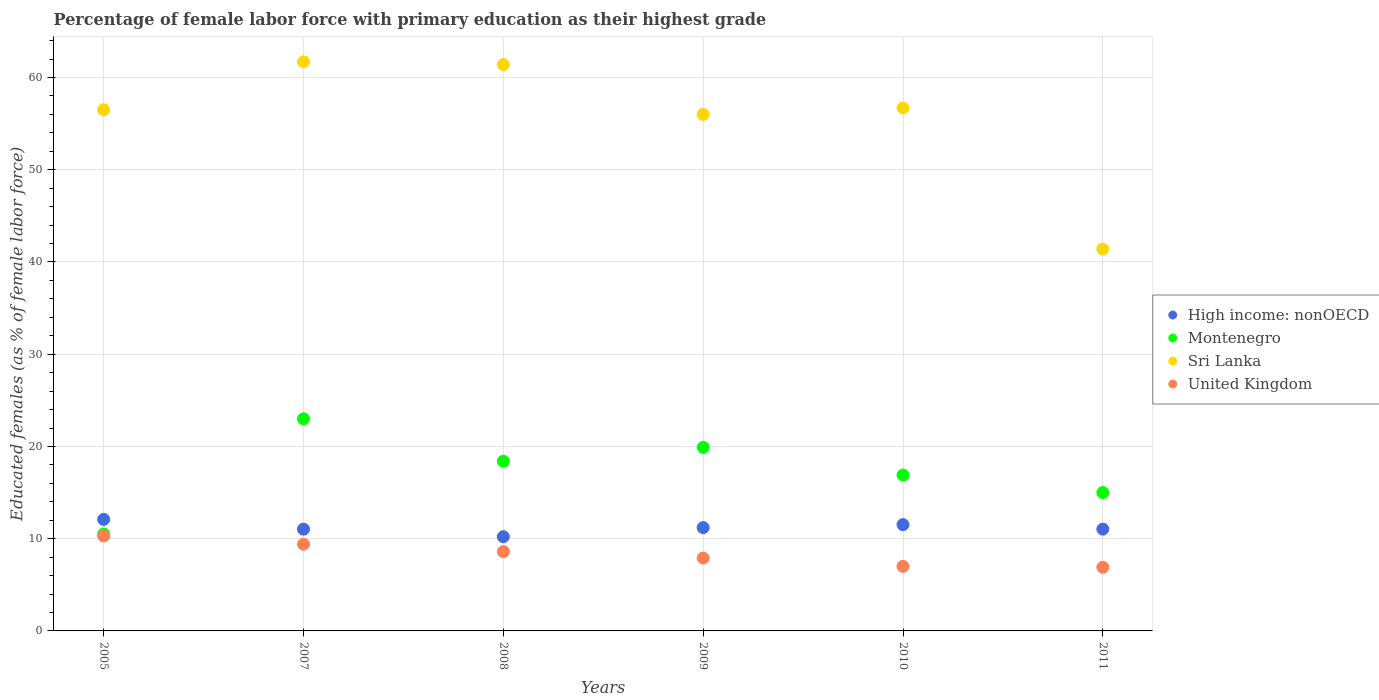Is the number of dotlines equal to the number of legend labels?
Ensure brevity in your answer.  Yes. What is the percentage of female labor force with primary education in United Kingdom in 2007?
Keep it short and to the point. 9.4. Across all years, what is the maximum percentage of female labor force with primary education in Montenegro?
Ensure brevity in your answer.  23. Across all years, what is the minimum percentage of female labor force with primary education in High income: nonOECD?
Give a very brief answer. 10.21. In which year was the percentage of female labor force with primary education in United Kingdom maximum?
Your answer should be very brief. 2005. In which year was the percentage of female labor force with primary education in High income: nonOECD minimum?
Ensure brevity in your answer.  2008. What is the total percentage of female labor force with primary education in United Kingdom in the graph?
Offer a terse response. 50.1. What is the difference between the percentage of female labor force with primary education in Sri Lanka in 2009 and that in 2011?
Your answer should be very brief. 14.6. What is the difference between the percentage of female labor force with primary education in Montenegro in 2011 and the percentage of female labor force with primary education in Sri Lanka in 2010?
Give a very brief answer. -41.7. What is the average percentage of female labor force with primary education in Montenegro per year?
Make the answer very short. 17.28. In the year 2007, what is the difference between the percentage of female labor force with primary education in High income: nonOECD and percentage of female labor force with primary education in Montenegro?
Make the answer very short. -11.97. In how many years, is the percentage of female labor force with primary education in Montenegro greater than 24 %?
Offer a terse response. 0. What is the ratio of the percentage of female labor force with primary education in High income: nonOECD in 2007 to that in 2011?
Make the answer very short. 1. Is the difference between the percentage of female labor force with primary education in High income: nonOECD in 2008 and 2011 greater than the difference between the percentage of female labor force with primary education in Montenegro in 2008 and 2011?
Give a very brief answer. No. What is the difference between the highest and the second highest percentage of female labor force with primary education in Sri Lanka?
Your answer should be very brief. 0.3. What is the difference between the highest and the lowest percentage of female labor force with primary education in United Kingdom?
Ensure brevity in your answer.  3.4. Is the sum of the percentage of female labor force with primary education in Sri Lanka in 2005 and 2009 greater than the maximum percentage of female labor force with primary education in Montenegro across all years?
Make the answer very short. Yes. Does the percentage of female labor force with primary education in Montenegro monotonically increase over the years?
Your response must be concise. No. How many dotlines are there?
Keep it short and to the point. 4. How many years are there in the graph?
Give a very brief answer. 6. What is the difference between two consecutive major ticks on the Y-axis?
Make the answer very short. 10. Does the graph contain any zero values?
Give a very brief answer. No. How many legend labels are there?
Keep it short and to the point. 4. How are the legend labels stacked?
Provide a succinct answer. Vertical. What is the title of the graph?
Make the answer very short. Percentage of female labor force with primary education as their highest grade. Does "Seychelles" appear as one of the legend labels in the graph?
Your answer should be compact. No. What is the label or title of the Y-axis?
Give a very brief answer. Educated females (as % of female labor force). What is the Educated females (as % of female labor force) of High income: nonOECD in 2005?
Keep it short and to the point. 12.09. What is the Educated females (as % of female labor force) in Montenegro in 2005?
Give a very brief answer. 10.5. What is the Educated females (as % of female labor force) in Sri Lanka in 2005?
Make the answer very short. 56.5. What is the Educated females (as % of female labor force) of United Kingdom in 2005?
Provide a short and direct response. 10.3. What is the Educated females (as % of female labor force) in High income: nonOECD in 2007?
Provide a succinct answer. 11.03. What is the Educated females (as % of female labor force) in Sri Lanka in 2007?
Provide a succinct answer. 61.7. What is the Educated females (as % of female labor force) of United Kingdom in 2007?
Provide a succinct answer. 9.4. What is the Educated females (as % of female labor force) of High income: nonOECD in 2008?
Provide a short and direct response. 10.21. What is the Educated females (as % of female labor force) of Montenegro in 2008?
Offer a very short reply. 18.4. What is the Educated females (as % of female labor force) in Sri Lanka in 2008?
Your answer should be compact. 61.4. What is the Educated females (as % of female labor force) in United Kingdom in 2008?
Your response must be concise. 8.6. What is the Educated females (as % of female labor force) of High income: nonOECD in 2009?
Give a very brief answer. 11.2. What is the Educated females (as % of female labor force) in Montenegro in 2009?
Ensure brevity in your answer.  19.9. What is the Educated females (as % of female labor force) in United Kingdom in 2009?
Provide a short and direct response. 7.9. What is the Educated females (as % of female labor force) in High income: nonOECD in 2010?
Your answer should be very brief. 11.53. What is the Educated females (as % of female labor force) of Montenegro in 2010?
Give a very brief answer. 16.9. What is the Educated females (as % of female labor force) in Sri Lanka in 2010?
Your response must be concise. 56.7. What is the Educated females (as % of female labor force) in United Kingdom in 2010?
Offer a terse response. 7. What is the Educated females (as % of female labor force) in High income: nonOECD in 2011?
Make the answer very short. 11.03. What is the Educated females (as % of female labor force) in Montenegro in 2011?
Your answer should be compact. 15. What is the Educated females (as % of female labor force) in Sri Lanka in 2011?
Offer a very short reply. 41.4. What is the Educated females (as % of female labor force) of United Kingdom in 2011?
Your answer should be compact. 6.9. Across all years, what is the maximum Educated females (as % of female labor force) in High income: nonOECD?
Give a very brief answer. 12.09. Across all years, what is the maximum Educated females (as % of female labor force) of Sri Lanka?
Keep it short and to the point. 61.7. Across all years, what is the maximum Educated females (as % of female labor force) of United Kingdom?
Make the answer very short. 10.3. Across all years, what is the minimum Educated females (as % of female labor force) in High income: nonOECD?
Offer a very short reply. 10.21. Across all years, what is the minimum Educated females (as % of female labor force) in Sri Lanka?
Keep it short and to the point. 41.4. Across all years, what is the minimum Educated females (as % of female labor force) in United Kingdom?
Provide a succinct answer. 6.9. What is the total Educated females (as % of female labor force) in High income: nonOECD in the graph?
Make the answer very short. 67.1. What is the total Educated females (as % of female labor force) in Montenegro in the graph?
Make the answer very short. 103.7. What is the total Educated females (as % of female labor force) of Sri Lanka in the graph?
Your answer should be very brief. 333.7. What is the total Educated females (as % of female labor force) in United Kingdom in the graph?
Your answer should be compact. 50.1. What is the difference between the Educated females (as % of female labor force) in High income: nonOECD in 2005 and that in 2007?
Make the answer very short. 1.06. What is the difference between the Educated females (as % of female labor force) of Montenegro in 2005 and that in 2007?
Provide a succinct answer. -12.5. What is the difference between the Educated females (as % of female labor force) in Sri Lanka in 2005 and that in 2007?
Provide a short and direct response. -5.2. What is the difference between the Educated females (as % of female labor force) in High income: nonOECD in 2005 and that in 2008?
Offer a terse response. 1.88. What is the difference between the Educated females (as % of female labor force) in Montenegro in 2005 and that in 2008?
Provide a short and direct response. -7.9. What is the difference between the Educated females (as % of female labor force) of United Kingdom in 2005 and that in 2008?
Ensure brevity in your answer.  1.7. What is the difference between the Educated females (as % of female labor force) in High income: nonOECD in 2005 and that in 2009?
Offer a terse response. 0.89. What is the difference between the Educated females (as % of female labor force) of Montenegro in 2005 and that in 2009?
Your response must be concise. -9.4. What is the difference between the Educated females (as % of female labor force) in High income: nonOECD in 2005 and that in 2010?
Provide a succinct answer. 0.57. What is the difference between the Educated females (as % of female labor force) of High income: nonOECD in 2005 and that in 2011?
Offer a very short reply. 1.06. What is the difference between the Educated females (as % of female labor force) of Sri Lanka in 2005 and that in 2011?
Your answer should be very brief. 15.1. What is the difference between the Educated females (as % of female labor force) in High income: nonOECD in 2007 and that in 2008?
Ensure brevity in your answer.  0.82. What is the difference between the Educated females (as % of female labor force) of Montenegro in 2007 and that in 2008?
Offer a terse response. 4.6. What is the difference between the Educated females (as % of female labor force) in Sri Lanka in 2007 and that in 2008?
Offer a very short reply. 0.3. What is the difference between the Educated females (as % of female labor force) of United Kingdom in 2007 and that in 2008?
Provide a succinct answer. 0.8. What is the difference between the Educated females (as % of female labor force) in High income: nonOECD in 2007 and that in 2009?
Your answer should be compact. -0.17. What is the difference between the Educated females (as % of female labor force) in United Kingdom in 2007 and that in 2009?
Your response must be concise. 1.5. What is the difference between the Educated females (as % of female labor force) in High income: nonOECD in 2007 and that in 2010?
Offer a very short reply. -0.49. What is the difference between the Educated females (as % of female labor force) in Montenegro in 2007 and that in 2010?
Your response must be concise. 6.1. What is the difference between the Educated females (as % of female labor force) in Sri Lanka in 2007 and that in 2010?
Your response must be concise. 5. What is the difference between the Educated females (as % of female labor force) of United Kingdom in 2007 and that in 2010?
Give a very brief answer. 2.4. What is the difference between the Educated females (as % of female labor force) of High income: nonOECD in 2007 and that in 2011?
Your answer should be very brief. -0. What is the difference between the Educated females (as % of female labor force) of Sri Lanka in 2007 and that in 2011?
Your answer should be compact. 20.3. What is the difference between the Educated females (as % of female labor force) of High income: nonOECD in 2008 and that in 2009?
Your answer should be compact. -0.99. What is the difference between the Educated females (as % of female labor force) in Montenegro in 2008 and that in 2009?
Your response must be concise. -1.5. What is the difference between the Educated females (as % of female labor force) in Sri Lanka in 2008 and that in 2009?
Make the answer very short. 5.4. What is the difference between the Educated females (as % of female labor force) in High income: nonOECD in 2008 and that in 2010?
Your answer should be compact. -1.31. What is the difference between the Educated females (as % of female labor force) of Montenegro in 2008 and that in 2010?
Keep it short and to the point. 1.5. What is the difference between the Educated females (as % of female labor force) of High income: nonOECD in 2008 and that in 2011?
Offer a very short reply. -0.82. What is the difference between the Educated females (as % of female labor force) in Montenegro in 2008 and that in 2011?
Give a very brief answer. 3.4. What is the difference between the Educated females (as % of female labor force) in United Kingdom in 2008 and that in 2011?
Make the answer very short. 1.7. What is the difference between the Educated females (as % of female labor force) of High income: nonOECD in 2009 and that in 2010?
Your answer should be compact. -0.33. What is the difference between the Educated females (as % of female labor force) of Sri Lanka in 2009 and that in 2010?
Give a very brief answer. -0.7. What is the difference between the Educated females (as % of female labor force) of United Kingdom in 2009 and that in 2010?
Make the answer very short. 0.9. What is the difference between the Educated females (as % of female labor force) of High income: nonOECD in 2009 and that in 2011?
Your answer should be very brief. 0.17. What is the difference between the Educated females (as % of female labor force) in United Kingdom in 2009 and that in 2011?
Provide a short and direct response. 1. What is the difference between the Educated females (as % of female labor force) in High income: nonOECD in 2010 and that in 2011?
Offer a terse response. 0.49. What is the difference between the Educated females (as % of female labor force) in United Kingdom in 2010 and that in 2011?
Ensure brevity in your answer.  0.1. What is the difference between the Educated females (as % of female labor force) of High income: nonOECD in 2005 and the Educated females (as % of female labor force) of Montenegro in 2007?
Offer a terse response. -10.91. What is the difference between the Educated females (as % of female labor force) in High income: nonOECD in 2005 and the Educated females (as % of female labor force) in Sri Lanka in 2007?
Provide a short and direct response. -49.61. What is the difference between the Educated females (as % of female labor force) of High income: nonOECD in 2005 and the Educated females (as % of female labor force) of United Kingdom in 2007?
Provide a succinct answer. 2.69. What is the difference between the Educated females (as % of female labor force) of Montenegro in 2005 and the Educated females (as % of female labor force) of Sri Lanka in 2007?
Keep it short and to the point. -51.2. What is the difference between the Educated females (as % of female labor force) of Montenegro in 2005 and the Educated females (as % of female labor force) of United Kingdom in 2007?
Offer a terse response. 1.1. What is the difference between the Educated females (as % of female labor force) of Sri Lanka in 2005 and the Educated females (as % of female labor force) of United Kingdom in 2007?
Keep it short and to the point. 47.1. What is the difference between the Educated females (as % of female labor force) in High income: nonOECD in 2005 and the Educated females (as % of female labor force) in Montenegro in 2008?
Give a very brief answer. -6.31. What is the difference between the Educated females (as % of female labor force) of High income: nonOECD in 2005 and the Educated females (as % of female labor force) of Sri Lanka in 2008?
Ensure brevity in your answer.  -49.31. What is the difference between the Educated females (as % of female labor force) of High income: nonOECD in 2005 and the Educated females (as % of female labor force) of United Kingdom in 2008?
Make the answer very short. 3.49. What is the difference between the Educated females (as % of female labor force) in Montenegro in 2005 and the Educated females (as % of female labor force) in Sri Lanka in 2008?
Provide a short and direct response. -50.9. What is the difference between the Educated females (as % of female labor force) in Sri Lanka in 2005 and the Educated females (as % of female labor force) in United Kingdom in 2008?
Offer a terse response. 47.9. What is the difference between the Educated females (as % of female labor force) in High income: nonOECD in 2005 and the Educated females (as % of female labor force) in Montenegro in 2009?
Your answer should be compact. -7.81. What is the difference between the Educated females (as % of female labor force) in High income: nonOECD in 2005 and the Educated females (as % of female labor force) in Sri Lanka in 2009?
Provide a short and direct response. -43.91. What is the difference between the Educated females (as % of female labor force) of High income: nonOECD in 2005 and the Educated females (as % of female labor force) of United Kingdom in 2009?
Give a very brief answer. 4.19. What is the difference between the Educated females (as % of female labor force) in Montenegro in 2005 and the Educated females (as % of female labor force) in Sri Lanka in 2009?
Give a very brief answer. -45.5. What is the difference between the Educated females (as % of female labor force) of Sri Lanka in 2005 and the Educated females (as % of female labor force) of United Kingdom in 2009?
Offer a very short reply. 48.6. What is the difference between the Educated females (as % of female labor force) of High income: nonOECD in 2005 and the Educated females (as % of female labor force) of Montenegro in 2010?
Keep it short and to the point. -4.81. What is the difference between the Educated females (as % of female labor force) in High income: nonOECD in 2005 and the Educated females (as % of female labor force) in Sri Lanka in 2010?
Provide a short and direct response. -44.61. What is the difference between the Educated females (as % of female labor force) of High income: nonOECD in 2005 and the Educated females (as % of female labor force) of United Kingdom in 2010?
Provide a short and direct response. 5.09. What is the difference between the Educated females (as % of female labor force) in Montenegro in 2005 and the Educated females (as % of female labor force) in Sri Lanka in 2010?
Your answer should be compact. -46.2. What is the difference between the Educated females (as % of female labor force) in Montenegro in 2005 and the Educated females (as % of female labor force) in United Kingdom in 2010?
Ensure brevity in your answer.  3.5. What is the difference between the Educated females (as % of female labor force) of Sri Lanka in 2005 and the Educated females (as % of female labor force) of United Kingdom in 2010?
Keep it short and to the point. 49.5. What is the difference between the Educated females (as % of female labor force) of High income: nonOECD in 2005 and the Educated females (as % of female labor force) of Montenegro in 2011?
Ensure brevity in your answer.  -2.91. What is the difference between the Educated females (as % of female labor force) of High income: nonOECD in 2005 and the Educated females (as % of female labor force) of Sri Lanka in 2011?
Offer a very short reply. -29.31. What is the difference between the Educated females (as % of female labor force) in High income: nonOECD in 2005 and the Educated females (as % of female labor force) in United Kingdom in 2011?
Your answer should be very brief. 5.19. What is the difference between the Educated females (as % of female labor force) of Montenegro in 2005 and the Educated females (as % of female labor force) of Sri Lanka in 2011?
Keep it short and to the point. -30.9. What is the difference between the Educated females (as % of female labor force) of Sri Lanka in 2005 and the Educated females (as % of female labor force) of United Kingdom in 2011?
Your response must be concise. 49.6. What is the difference between the Educated females (as % of female labor force) of High income: nonOECD in 2007 and the Educated females (as % of female labor force) of Montenegro in 2008?
Your response must be concise. -7.37. What is the difference between the Educated females (as % of female labor force) of High income: nonOECD in 2007 and the Educated females (as % of female labor force) of Sri Lanka in 2008?
Provide a short and direct response. -50.37. What is the difference between the Educated females (as % of female labor force) of High income: nonOECD in 2007 and the Educated females (as % of female labor force) of United Kingdom in 2008?
Make the answer very short. 2.43. What is the difference between the Educated females (as % of female labor force) of Montenegro in 2007 and the Educated females (as % of female labor force) of Sri Lanka in 2008?
Ensure brevity in your answer.  -38.4. What is the difference between the Educated females (as % of female labor force) in Sri Lanka in 2007 and the Educated females (as % of female labor force) in United Kingdom in 2008?
Provide a short and direct response. 53.1. What is the difference between the Educated females (as % of female labor force) in High income: nonOECD in 2007 and the Educated females (as % of female labor force) in Montenegro in 2009?
Keep it short and to the point. -8.87. What is the difference between the Educated females (as % of female labor force) of High income: nonOECD in 2007 and the Educated females (as % of female labor force) of Sri Lanka in 2009?
Ensure brevity in your answer.  -44.97. What is the difference between the Educated females (as % of female labor force) of High income: nonOECD in 2007 and the Educated females (as % of female labor force) of United Kingdom in 2009?
Provide a succinct answer. 3.13. What is the difference between the Educated females (as % of female labor force) in Montenegro in 2007 and the Educated females (as % of female labor force) in Sri Lanka in 2009?
Give a very brief answer. -33. What is the difference between the Educated females (as % of female labor force) of Montenegro in 2007 and the Educated females (as % of female labor force) of United Kingdom in 2009?
Provide a short and direct response. 15.1. What is the difference between the Educated females (as % of female labor force) in Sri Lanka in 2007 and the Educated females (as % of female labor force) in United Kingdom in 2009?
Make the answer very short. 53.8. What is the difference between the Educated females (as % of female labor force) of High income: nonOECD in 2007 and the Educated females (as % of female labor force) of Montenegro in 2010?
Your answer should be very brief. -5.87. What is the difference between the Educated females (as % of female labor force) of High income: nonOECD in 2007 and the Educated females (as % of female labor force) of Sri Lanka in 2010?
Your response must be concise. -45.67. What is the difference between the Educated females (as % of female labor force) of High income: nonOECD in 2007 and the Educated females (as % of female labor force) of United Kingdom in 2010?
Offer a terse response. 4.03. What is the difference between the Educated females (as % of female labor force) of Montenegro in 2007 and the Educated females (as % of female labor force) of Sri Lanka in 2010?
Provide a short and direct response. -33.7. What is the difference between the Educated females (as % of female labor force) in Montenegro in 2007 and the Educated females (as % of female labor force) in United Kingdom in 2010?
Offer a terse response. 16. What is the difference between the Educated females (as % of female labor force) of Sri Lanka in 2007 and the Educated females (as % of female labor force) of United Kingdom in 2010?
Your answer should be very brief. 54.7. What is the difference between the Educated females (as % of female labor force) of High income: nonOECD in 2007 and the Educated females (as % of female labor force) of Montenegro in 2011?
Offer a terse response. -3.97. What is the difference between the Educated females (as % of female labor force) in High income: nonOECD in 2007 and the Educated females (as % of female labor force) in Sri Lanka in 2011?
Ensure brevity in your answer.  -30.37. What is the difference between the Educated females (as % of female labor force) of High income: nonOECD in 2007 and the Educated females (as % of female labor force) of United Kingdom in 2011?
Provide a short and direct response. 4.13. What is the difference between the Educated females (as % of female labor force) of Montenegro in 2007 and the Educated females (as % of female labor force) of Sri Lanka in 2011?
Offer a very short reply. -18.4. What is the difference between the Educated females (as % of female labor force) of Sri Lanka in 2007 and the Educated females (as % of female labor force) of United Kingdom in 2011?
Your response must be concise. 54.8. What is the difference between the Educated females (as % of female labor force) of High income: nonOECD in 2008 and the Educated females (as % of female labor force) of Montenegro in 2009?
Your answer should be compact. -9.69. What is the difference between the Educated females (as % of female labor force) in High income: nonOECD in 2008 and the Educated females (as % of female labor force) in Sri Lanka in 2009?
Give a very brief answer. -45.79. What is the difference between the Educated females (as % of female labor force) of High income: nonOECD in 2008 and the Educated females (as % of female labor force) of United Kingdom in 2009?
Offer a very short reply. 2.31. What is the difference between the Educated females (as % of female labor force) in Montenegro in 2008 and the Educated females (as % of female labor force) in Sri Lanka in 2009?
Your answer should be compact. -37.6. What is the difference between the Educated females (as % of female labor force) in Sri Lanka in 2008 and the Educated females (as % of female labor force) in United Kingdom in 2009?
Your answer should be very brief. 53.5. What is the difference between the Educated females (as % of female labor force) in High income: nonOECD in 2008 and the Educated females (as % of female labor force) in Montenegro in 2010?
Give a very brief answer. -6.69. What is the difference between the Educated females (as % of female labor force) in High income: nonOECD in 2008 and the Educated females (as % of female labor force) in Sri Lanka in 2010?
Give a very brief answer. -46.49. What is the difference between the Educated females (as % of female labor force) of High income: nonOECD in 2008 and the Educated females (as % of female labor force) of United Kingdom in 2010?
Your answer should be compact. 3.21. What is the difference between the Educated females (as % of female labor force) in Montenegro in 2008 and the Educated females (as % of female labor force) in Sri Lanka in 2010?
Provide a short and direct response. -38.3. What is the difference between the Educated females (as % of female labor force) in Montenegro in 2008 and the Educated females (as % of female labor force) in United Kingdom in 2010?
Offer a very short reply. 11.4. What is the difference between the Educated females (as % of female labor force) in Sri Lanka in 2008 and the Educated females (as % of female labor force) in United Kingdom in 2010?
Provide a succinct answer. 54.4. What is the difference between the Educated females (as % of female labor force) in High income: nonOECD in 2008 and the Educated females (as % of female labor force) in Montenegro in 2011?
Your response must be concise. -4.79. What is the difference between the Educated females (as % of female labor force) in High income: nonOECD in 2008 and the Educated females (as % of female labor force) in Sri Lanka in 2011?
Offer a terse response. -31.19. What is the difference between the Educated females (as % of female labor force) of High income: nonOECD in 2008 and the Educated females (as % of female labor force) of United Kingdom in 2011?
Offer a very short reply. 3.31. What is the difference between the Educated females (as % of female labor force) of Montenegro in 2008 and the Educated females (as % of female labor force) of Sri Lanka in 2011?
Your answer should be compact. -23. What is the difference between the Educated females (as % of female labor force) in Montenegro in 2008 and the Educated females (as % of female labor force) in United Kingdom in 2011?
Your answer should be very brief. 11.5. What is the difference between the Educated females (as % of female labor force) of Sri Lanka in 2008 and the Educated females (as % of female labor force) of United Kingdom in 2011?
Ensure brevity in your answer.  54.5. What is the difference between the Educated females (as % of female labor force) of High income: nonOECD in 2009 and the Educated females (as % of female labor force) of Montenegro in 2010?
Give a very brief answer. -5.7. What is the difference between the Educated females (as % of female labor force) of High income: nonOECD in 2009 and the Educated females (as % of female labor force) of Sri Lanka in 2010?
Give a very brief answer. -45.5. What is the difference between the Educated females (as % of female labor force) of High income: nonOECD in 2009 and the Educated females (as % of female labor force) of United Kingdom in 2010?
Give a very brief answer. 4.2. What is the difference between the Educated females (as % of female labor force) in Montenegro in 2009 and the Educated females (as % of female labor force) in Sri Lanka in 2010?
Make the answer very short. -36.8. What is the difference between the Educated females (as % of female labor force) of Montenegro in 2009 and the Educated females (as % of female labor force) of United Kingdom in 2010?
Your answer should be compact. 12.9. What is the difference between the Educated females (as % of female labor force) in High income: nonOECD in 2009 and the Educated females (as % of female labor force) in Montenegro in 2011?
Your response must be concise. -3.8. What is the difference between the Educated females (as % of female labor force) of High income: nonOECD in 2009 and the Educated females (as % of female labor force) of Sri Lanka in 2011?
Keep it short and to the point. -30.2. What is the difference between the Educated females (as % of female labor force) in High income: nonOECD in 2009 and the Educated females (as % of female labor force) in United Kingdom in 2011?
Provide a short and direct response. 4.3. What is the difference between the Educated females (as % of female labor force) of Montenegro in 2009 and the Educated females (as % of female labor force) of Sri Lanka in 2011?
Offer a very short reply. -21.5. What is the difference between the Educated females (as % of female labor force) in Montenegro in 2009 and the Educated females (as % of female labor force) in United Kingdom in 2011?
Your answer should be compact. 13. What is the difference between the Educated females (as % of female labor force) in Sri Lanka in 2009 and the Educated females (as % of female labor force) in United Kingdom in 2011?
Make the answer very short. 49.1. What is the difference between the Educated females (as % of female labor force) of High income: nonOECD in 2010 and the Educated females (as % of female labor force) of Montenegro in 2011?
Keep it short and to the point. -3.47. What is the difference between the Educated females (as % of female labor force) in High income: nonOECD in 2010 and the Educated females (as % of female labor force) in Sri Lanka in 2011?
Provide a succinct answer. -29.87. What is the difference between the Educated females (as % of female labor force) of High income: nonOECD in 2010 and the Educated females (as % of female labor force) of United Kingdom in 2011?
Provide a succinct answer. 4.63. What is the difference between the Educated females (as % of female labor force) in Montenegro in 2010 and the Educated females (as % of female labor force) in Sri Lanka in 2011?
Provide a succinct answer. -24.5. What is the difference between the Educated females (as % of female labor force) in Sri Lanka in 2010 and the Educated females (as % of female labor force) in United Kingdom in 2011?
Ensure brevity in your answer.  49.8. What is the average Educated females (as % of female labor force) in High income: nonOECD per year?
Your response must be concise. 11.18. What is the average Educated females (as % of female labor force) of Montenegro per year?
Provide a short and direct response. 17.28. What is the average Educated females (as % of female labor force) in Sri Lanka per year?
Your answer should be very brief. 55.62. What is the average Educated females (as % of female labor force) of United Kingdom per year?
Offer a terse response. 8.35. In the year 2005, what is the difference between the Educated females (as % of female labor force) of High income: nonOECD and Educated females (as % of female labor force) of Montenegro?
Offer a terse response. 1.59. In the year 2005, what is the difference between the Educated females (as % of female labor force) in High income: nonOECD and Educated females (as % of female labor force) in Sri Lanka?
Your answer should be compact. -44.41. In the year 2005, what is the difference between the Educated females (as % of female labor force) of High income: nonOECD and Educated females (as % of female labor force) of United Kingdom?
Your answer should be very brief. 1.79. In the year 2005, what is the difference between the Educated females (as % of female labor force) in Montenegro and Educated females (as % of female labor force) in Sri Lanka?
Your answer should be compact. -46. In the year 2005, what is the difference between the Educated females (as % of female labor force) in Montenegro and Educated females (as % of female labor force) in United Kingdom?
Your response must be concise. 0.2. In the year 2005, what is the difference between the Educated females (as % of female labor force) of Sri Lanka and Educated females (as % of female labor force) of United Kingdom?
Offer a very short reply. 46.2. In the year 2007, what is the difference between the Educated females (as % of female labor force) of High income: nonOECD and Educated females (as % of female labor force) of Montenegro?
Ensure brevity in your answer.  -11.97. In the year 2007, what is the difference between the Educated females (as % of female labor force) in High income: nonOECD and Educated females (as % of female labor force) in Sri Lanka?
Provide a short and direct response. -50.67. In the year 2007, what is the difference between the Educated females (as % of female labor force) of High income: nonOECD and Educated females (as % of female labor force) of United Kingdom?
Offer a very short reply. 1.63. In the year 2007, what is the difference between the Educated females (as % of female labor force) in Montenegro and Educated females (as % of female labor force) in Sri Lanka?
Provide a short and direct response. -38.7. In the year 2007, what is the difference between the Educated females (as % of female labor force) of Montenegro and Educated females (as % of female labor force) of United Kingdom?
Keep it short and to the point. 13.6. In the year 2007, what is the difference between the Educated females (as % of female labor force) in Sri Lanka and Educated females (as % of female labor force) in United Kingdom?
Your answer should be very brief. 52.3. In the year 2008, what is the difference between the Educated females (as % of female labor force) in High income: nonOECD and Educated females (as % of female labor force) in Montenegro?
Your answer should be compact. -8.19. In the year 2008, what is the difference between the Educated females (as % of female labor force) of High income: nonOECD and Educated females (as % of female labor force) of Sri Lanka?
Your answer should be very brief. -51.19. In the year 2008, what is the difference between the Educated females (as % of female labor force) of High income: nonOECD and Educated females (as % of female labor force) of United Kingdom?
Make the answer very short. 1.61. In the year 2008, what is the difference between the Educated females (as % of female labor force) of Montenegro and Educated females (as % of female labor force) of Sri Lanka?
Your answer should be very brief. -43. In the year 2008, what is the difference between the Educated females (as % of female labor force) of Sri Lanka and Educated females (as % of female labor force) of United Kingdom?
Make the answer very short. 52.8. In the year 2009, what is the difference between the Educated females (as % of female labor force) of High income: nonOECD and Educated females (as % of female labor force) of Montenegro?
Ensure brevity in your answer.  -8.7. In the year 2009, what is the difference between the Educated females (as % of female labor force) of High income: nonOECD and Educated females (as % of female labor force) of Sri Lanka?
Offer a very short reply. -44.8. In the year 2009, what is the difference between the Educated females (as % of female labor force) in High income: nonOECD and Educated females (as % of female labor force) in United Kingdom?
Provide a short and direct response. 3.3. In the year 2009, what is the difference between the Educated females (as % of female labor force) of Montenegro and Educated females (as % of female labor force) of Sri Lanka?
Ensure brevity in your answer.  -36.1. In the year 2009, what is the difference between the Educated females (as % of female labor force) of Montenegro and Educated females (as % of female labor force) of United Kingdom?
Offer a very short reply. 12. In the year 2009, what is the difference between the Educated females (as % of female labor force) in Sri Lanka and Educated females (as % of female labor force) in United Kingdom?
Keep it short and to the point. 48.1. In the year 2010, what is the difference between the Educated females (as % of female labor force) in High income: nonOECD and Educated females (as % of female labor force) in Montenegro?
Your answer should be compact. -5.37. In the year 2010, what is the difference between the Educated females (as % of female labor force) in High income: nonOECD and Educated females (as % of female labor force) in Sri Lanka?
Ensure brevity in your answer.  -45.17. In the year 2010, what is the difference between the Educated females (as % of female labor force) of High income: nonOECD and Educated females (as % of female labor force) of United Kingdom?
Offer a very short reply. 4.53. In the year 2010, what is the difference between the Educated females (as % of female labor force) in Montenegro and Educated females (as % of female labor force) in Sri Lanka?
Provide a short and direct response. -39.8. In the year 2010, what is the difference between the Educated females (as % of female labor force) of Montenegro and Educated females (as % of female labor force) of United Kingdom?
Your answer should be very brief. 9.9. In the year 2010, what is the difference between the Educated females (as % of female labor force) of Sri Lanka and Educated females (as % of female labor force) of United Kingdom?
Offer a very short reply. 49.7. In the year 2011, what is the difference between the Educated females (as % of female labor force) of High income: nonOECD and Educated females (as % of female labor force) of Montenegro?
Offer a very short reply. -3.97. In the year 2011, what is the difference between the Educated females (as % of female labor force) in High income: nonOECD and Educated females (as % of female labor force) in Sri Lanka?
Your answer should be very brief. -30.37. In the year 2011, what is the difference between the Educated females (as % of female labor force) of High income: nonOECD and Educated females (as % of female labor force) of United Kingdom?
Your answer should be compact. 4.13. In the year 2011, what is the difference between the Educated females (as % of female labor force) in Montenegro and Educated females (as % of female labor force) in Sri Lanka?
Offer a very short reply. -26.4. In the year 2011, what is the difference between the Educated females (as % of female labor force) of Montenegro and Educated females (as % of female labor force) of United Kingdom?
Make the answer very short. 8.1. In the year 2011, what is the difference between the Educated females (as % of female labor force) in Sri Lanka and Educated females (as % of female labor force) in United Kingdom?
Offer a very short reply. 34.5. What is the ratio of the Educated females (as % of female labor force) in High income: nonOECD in 2005 to that in 2007?
Your response must be concise. 1.1. What is the ratio of the Educated females (as % of female labor force) of Montenegro in 2005 to that in 2007?
Your answer should be compact. 0.46. What is the ratio of the Educated females (as % of female labor force) in Sri Lanka in 2005 to that in 2007?
Offer a very short reply. 0.92. What is the ratio of the Educated females (as % of female labor force) in United Kingdom in 2005 to that in 2007?
Your answer should be very brief. 1.1. What is the ratio of the Educated females (as % of female labor force) of High income: nonOECD in 2005 to that in 2008?
Keep it short and to the point. 1.18. What is the ratio of the Educated females (as % of female labor force) in Montenegro in 2005 to that in 2008?
Your answer should be very brief. 0.57. What is the ratio of the Educated females (as % of female labor force) of Sri Lanka in 2005 to that in 2008?
Provide a short and direct response. 0.92. What is the ratio of the Educated females (as % of female labor force) of United Kingdom in 2005 to that in 2008?
Give a very brief answer. 1.2. What is the ratio of the Educated females (as % of female labor force) of High income: nonOECD in 2005 to that in 2009?
Provide a succinct answer. 1.08. What is the ratio of the Educated females (as % of female labor force) of Montenegro in 2005 to that in 2009?
Your answer should be very brief. 0.53. What is the ratio of the Educated females (as % of female labor force) in Sri Lanka in 2005 to that in 2009?
Your answer should be compact. 1.01. What is the ratio of the Educated females (as % of female labor force) in United Kingdom in 2005 to that in 2009?
Keep it short and to the point. 1.3. What is the ratio of the Educated females (as % of female labor force) of High income: nonOECD in 2005 to that in 2010?
Your answer should be compact. 1.05. What is the ratio of the Educated females (as % of female labor force) in Montenegro in 2005 to that in 2010?
Your answer should be compact. 0.62. What is the ratio of the Educated females (as % of female labor force) of United Kingdom in 2005 to that in 2010?
Your answer should be compact. 1.47. What is the ratio of the Educated females (as % of female labor force) in High income: nonOECD in 2005 to that in 2011?
Provide a succinct answer. 1.1. What is the ratio of the Educated females (as % of female labor force) in Montenegro in 2005 to that in 2011?
Offer a terse response. 0.7. What is the ratio of the Educated females (as % of female labor force) of Sri Lanka in 2005 to that in 2011?
Ensure brevity in your answer.  1.36. What is the ratio of the Educated females (as % of female labor force) in United Kingdom in 2005 to that in 2011?
Keep it short and to the point. 1.49. What is the ratio of the Educated females (as % of female labor force) of High income: nonOECD in 2007 to that in 2008?
Provide a short and direct response. 1.08. What is the ratio of the Educated females (as % of female labor force) in Sri Lanka in 2007 to that in 2008?
Offer a terse response. 1. What is the ratio of the Educated females (as % of female labor force) in United Kingdom in 2007 to that in 2008?
Keep it short and to the point. 1.09. What is the ratio of the Educated females (as % of female labor force) in High income: nonOECD in 2007 to that in 2009?
Give a very brief answer. 0.98. What is the ratio of the Educated females (as % of female labor force) in Montenegro in 2007 to that in 2009?
Your answer should be very brief. 1.16. What is the ratio of the Educated females (as % of female labor force) in Sri Lanka in 2007 to that in 2009?
Keep it short and to the point. 1.1. What is the ratio of the Educated females (as % of female labor force) in United Kingdom in 2007 to that in 2009?
Your answer should be compact. 1.19. What is the ratio of the Educated females (as % of female labor force) in High income: nonOECD in 2007 to that in 2010?
Ensure brevity in your answer.  0.96. What is the ratio of the Educated females (as % of female labor force) in Montenegro in 2007 to that in 2010?
Offer a terse response. 1.36. What is the ratio of the Educated females (as % of female labor force) of Sri Lanka in 2007 to that in 2010?
Your answer should be very brief. 1.09. What is the ratio of the Educated females (as % of female labor force) in United Kingdom in 2007 to that in 2010?
Give a very brief answer. 1.34. What is the ratio of the Educated females (as % of female labor force) of Montenegro in 2007 to that in 2011?
Offer a very short reply. 1.53. What is the ratio of the Educated females (as % of female labor force) of Sri Lanka in 2007 to that in 2011?
Make the answer very short. 1.49. What is the ratio of the Educated females (as % of female labor force) of United Kingdom in 2007 to that in 2011?
Provide a short and direct response. 1.36. What is the ratio of the Educated females (as % of female labor force) of High income: nonOECD in 2008 to that in 2009?
Your response must be concise. 0.91. What is the ratio of the Educated females (as % of female labor force) of Montenegro in 2008 to that in 2009?
Make the answer very short. 0.92. What is the ratio of the Educated females (as % of female labor force) in Sri Lanka in 2008 to that in 2009?
Offer a terse response. 1.1. What is the ratio of the Educated females (as % of female labor force) in United Kingdom in 2008 to that in 2009?
Offer a terse response. 1.09. What is the ratio of the Educated females (as % of female labor force) of High income: nonOECD in 2008 to that in 2010?
Provide a succinct answer. 0.89. What is the ratio of the Educated females (as % of female labor force) in Montenegro in 2008 to that in 2010?
Give a very brief answer. 1.09. What is the ratio of the Educated females (as % of female labor force) of Sri Lanka in 2008 to that in 2010?
Your answer should be compact. 1.08. What is the ratio of the Educated females (as % of female labor force) in United Kingdom in 2008 to that in 2010?
Your response must be concise. 1.23. What is the ratio of the Educated females (as % of female labor force) in High income: nonOECD in 2008 to that in 2011?
Make the answer very short. 0.93. What is the ratio of the Educated females (as % of female labor force) of Montenegro in 2008 to that in 2011?
Give a very brief answer. 1.23. What is the ratio of the Educated females (as % of female labor force) of Sri Lanka in 2008 to that in 2011?
Provide a succinct answer. 1.48. What is the ratio of the Educated females (as % of female labor force) of United Kingdom in 2008 to that in 2011?
Keep it short and to the point. 1.25. What is the ratio of the Educated females (as % of female labor force) of High income: nonOECD in 2009 to that in 2010?
Your answer should be compact. 0.97. What is the ratio of the Educated females (as % of female labor force) of Montenegro in 2009 to that in 2010?
Offer a terse response. 1.18. What is the ratio of the Educated females (as % of female labor force) in United Kingdom in 2009 to that in 2010?
Give a very brief answer. 1.13. What is the ratio of the Educated females (as % of female labor force) of High income: nonOECD in 2009 to that in 2011?
Provide a succinct answer. 1.01. What is the ratio of the Educated females (as % of female labor force) in Montenegro in 2009 to that in 2011?
Keep it short and to the point. 1.33. What is the ratio of the Educated females (as % of female labor force) in Sri Lanka in 2009 to that in 2011?
Provide a short and direct response. 1.35. What is the ratio of the Educated females (as % of female labor force) of United Kingdom in 2009 to that in 2011?
Your answer should be compact. 1.14. What is the ratio of the Educated females (as % of female labor force) of High income: nonOECD in 2010 to that in 2011?
Offer a very short reply. 1.04. What is the ratio of the Educated females (as % of female labor force) in Montenegro in 2010 to that in 2011?
Provide a short and direct response. 1.13. What is the ratio of the Educated females (as % of female labor force) of Sri Lanka in 2010 to that in 2011?
Provide a short and direct response. 1.37. What is the ratio of the Educated females (as % of female labor force) of United Kingdom in 2010 to that in 2011?
Provide a short and direct response. 1.01. What is the difference between the highest and the second highest Educated females (as % of female labor force) of High income: nonOECD?
Provide a succinct answer. 0.57. What is the difference between the highest and the second highest Educated females (as % of female labor force) of Sri Lanka?
Offer a very short reply. 0.3. What is the difference between the highest and the second highest Educated females (as % of female labor force) in United Kingdom?
Ensure brevity in your answer.  0.9. What is the difference between the highest and the lowest Educated females (as % of female labor force) in High income: nonOECD?
Give a very brief answer. 1.88. What is the difference between the highest and the lowest Educated females (as % of female labor force) in Montenegro?
Ensure brevity in your answer.  12.5. What is the difference between the highest and the lowest Educated females (as % of female labor force) of Sri Lanka?
Offer a terse response. 20.3. 